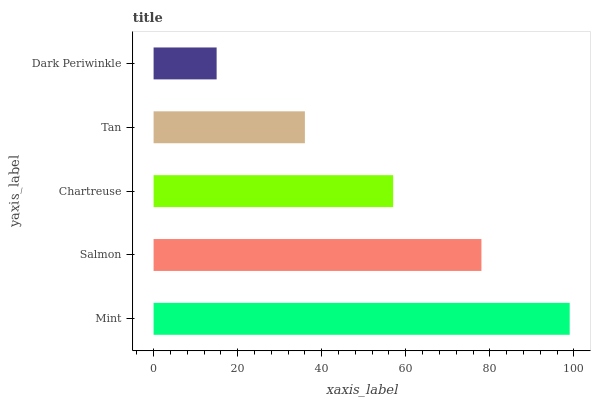Is Dark Periwinkle the minimum?
Answer yes or no. Yes. Is Mint the maximum?
Answer yes or no. Yes. Is Salmon the minimum?
Answer yes or no. No. Is Salmon the maximum?
Answer yes or no. No. Is Mint greater than Salmon?
Answer yes or no. Yes. Is Salmon less than Mint?
Answer yes or no. Yes. Is Salmon greater than Mint?
Answer yes or no. No. Is Mint less than Salmon?
Answer yes or no. No. Is Chartreuse the high median?
Answer yes or no. Yes. Is Chartreuse the low median?
Answer yes or no. Yes. Is Mint the high median?
Answer yes or no. No. Is Tan the low median?
Answer yes or no. No. 